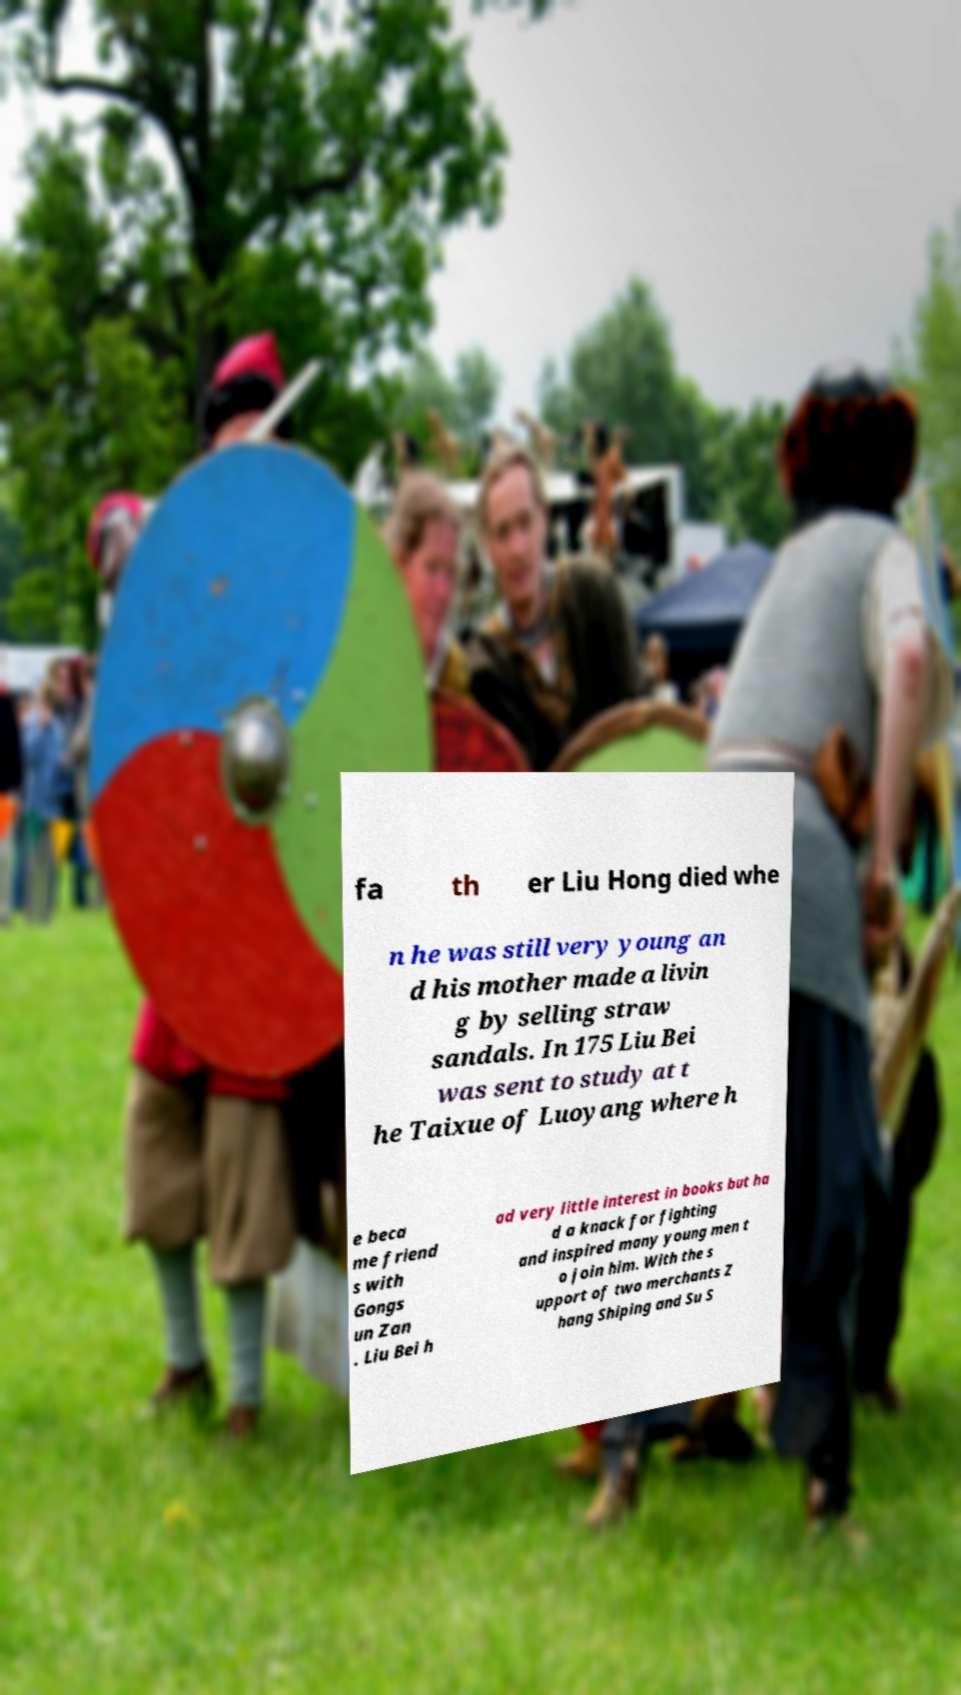Could you extract and type out the text from this image? fa th er Liu Hong died whe n he was still very young an d his mother made a livin g by selling straw sandals. In 175 Liu Bei was sent to study at t he Taixue of Luoyang where h e beca me friend s with Gongs un Zan . Liu Bei h ad very little interest in books but ha d a knack for fighting and inspired many young men t o join him. With the s upport of two merchants Z hang Shiping and Su S 